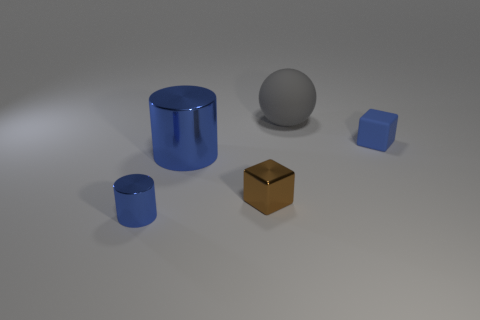What color is the metal cylinder that is the same size as the matte block?
Make the answer very short. Blue. There is a large blue metallic object; does it have the same shape as the tiny blue object that is in front of the small brown metal thing?
Give a very brief answer. Yes. There is a blue cylinder that is on the right side of the metallic cylinder that is on the left side of the large object that is left of the brown cube; what is it made of?
Ensure brevity in your answer.  Metal. How many small objects are either metal blocks or metallic objects?
Your response must be concise. 2. What number of other things are the same size as the gray rubber ball?
Provide a succinct answer. 1. Does the small thing that is behind the brown object have the same shape as the brown metal thing?
Keep it short and to the point. Yes. There is a small metal thing that is the same shape as the tiny blue rubber object; what is its color?
Your answer should be very brief. Brown. Are there any other things that are the same shape as the gray matte thing?
Your response must be concise. No. Are there an equal number of small cubes that are right of the blue block and small cyan shiny cubes?
Give a very brief answer. Yes. What number of objects are in front of the gray matte object and to the right of the small brown object?
Provide a short and direct response. 1. 